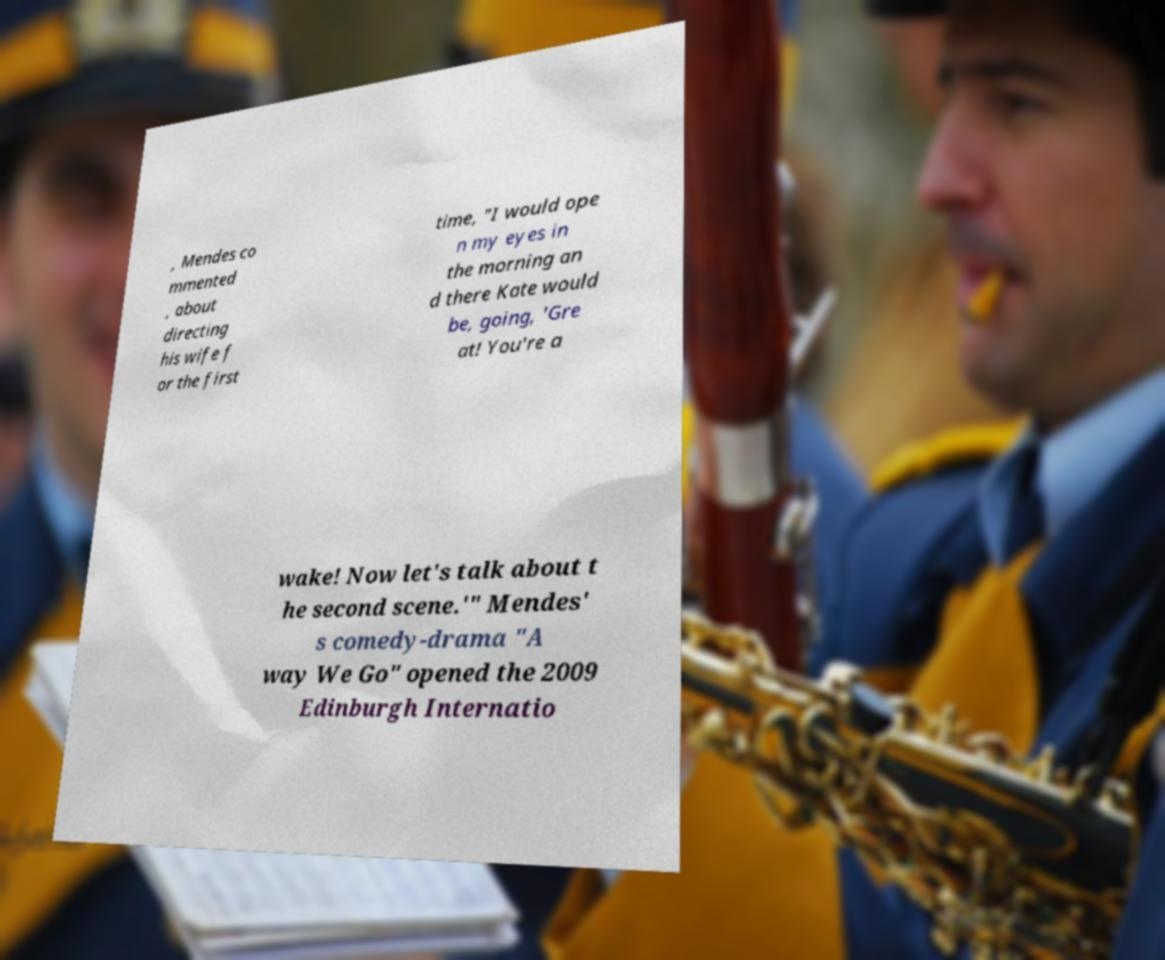I need the written content from this picture converted into text. Can you do that? , Mendes co mmented , about directing his wife f or the first time, "I would ope n my eyes in the morning an d there Kate would be, going, 'Gre at! You're a wake! Now let's talk about t he second scene.'" Mendes' s comedy-drama "A way We Go" opened the 2009 Edinburgh Internatio 